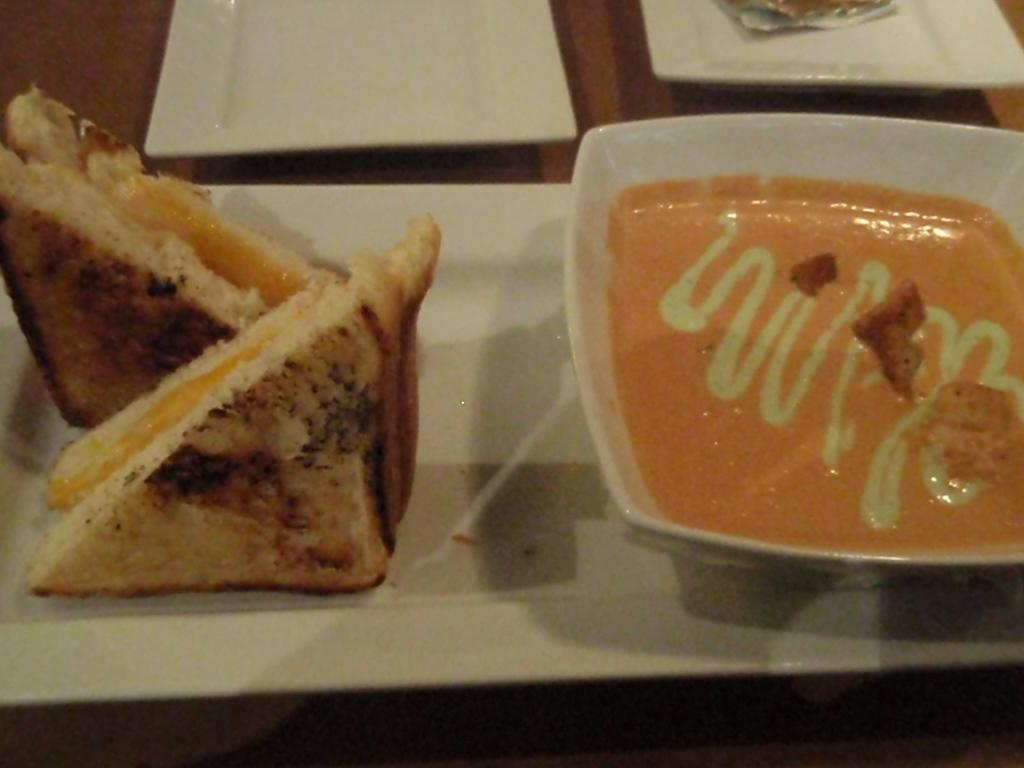What object is present in the image that can hold multiple items? There is a tray in the image. What can be found on the left side of the tray? There is a food item on the left side of the tray. What is located on the right side of the tray? There is a bowl with a food item on the right side of the tray. What type of badge is being worn by the food item on the left side of the tray? There is no badge present in the image, as the image features a tray with food items and not people or objects that would typically wear badges. 